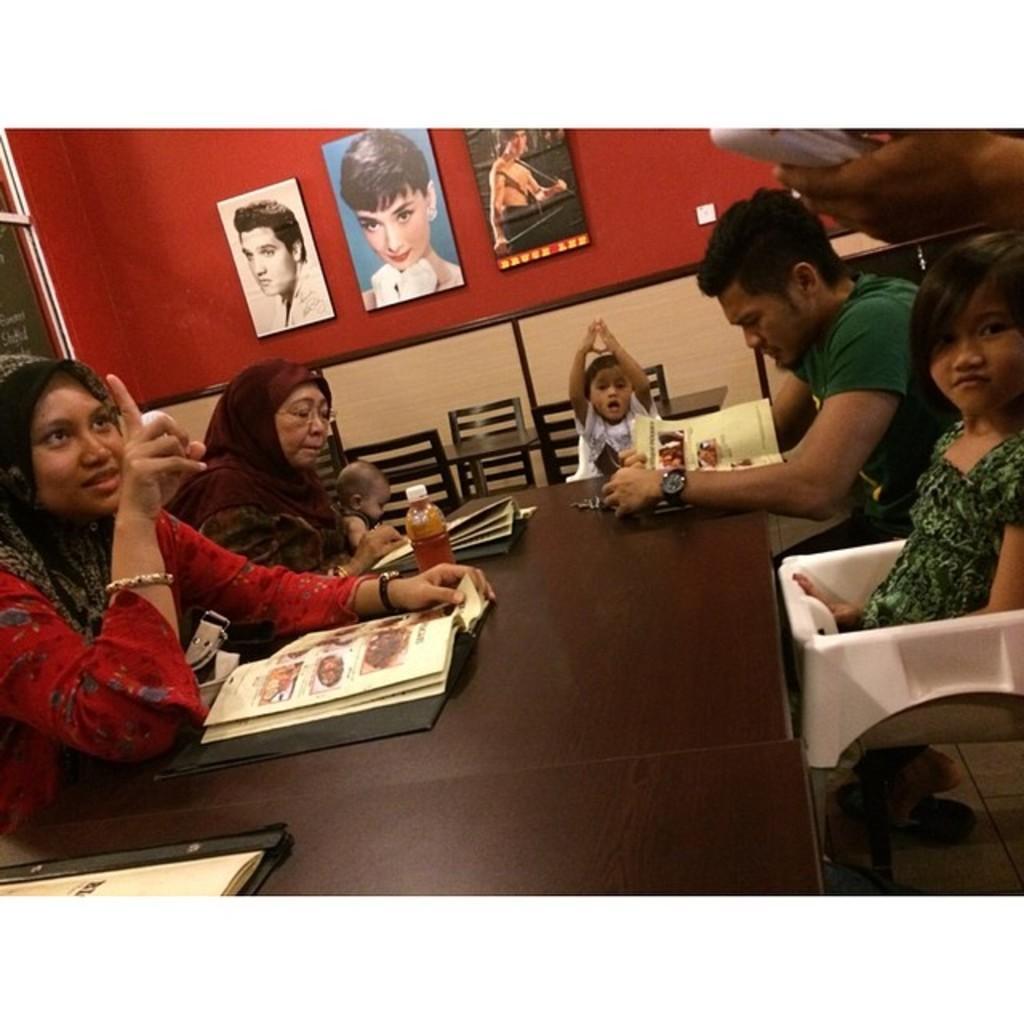Can you describe this image briefly? In this picture we can see a family ordering a food. These are photo frames which are fixed to a wall. 